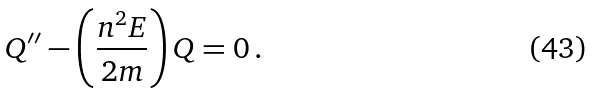<formula> <loc_0><loc_0><loc_500><loc_500>Q ^ { \prime \prime } - \left ( \frac { n ^ { 2 } E } { 2 m } \right ) Q = 0 \, .</formula> 